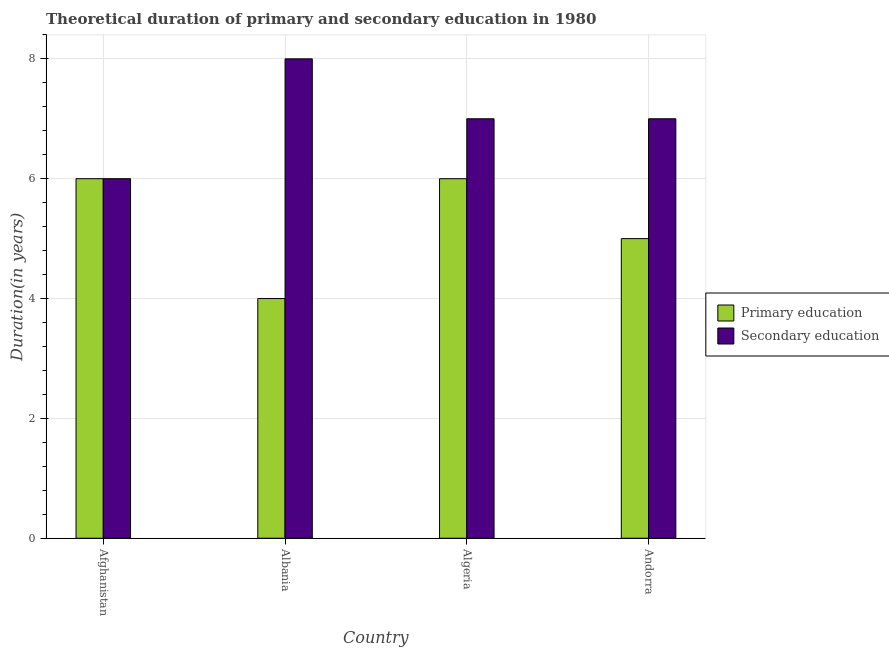How many different coloured bars are there?
Your response must be concise. 2. How many groups of bars are there?
Your answer should be compact. 4. Are the number of bars on each tick of the X-axis equal?
Your answer should be compact. Yes. How many bars are there on the 3rd tick from the left?
Give a very brief answer. 2. What is the label of the 1st group of bars from the left?
Provide a short and direct response. Afghanistan. What is the duration of secondary education in Albania?
Offer a very short reply. 8. Across all countries, what is the maximum duration of secondary education?
Ensure brevity in your answer.  8. In which country was the duration of secondary education maximum?
Provide a short and direct response. Albania. In which country was the duration of primary education minimum?
Make the answer very short. Albania. What is the total duration of primary education in the graph?
Your answer should be compact. 21. What is the difference between the duration of primary education in Albania and that in Andorra?
Your answer should be very brief. -1. What is the difference between the duration of primary education in Algeria and the duration of secondary education in Albania?
Your answer should be very brief. -2. What is the average duration of primary education per country?
Make the answer very short. 5.25. In how many countries, is the duration of secondary education greater than 5.6 years?
Offer a terse response. 4. What is the ratio of the duration of secondary education in Albania to that in Algeria?
Give a very brief answer. 1.14. Is the duration of primary education in Afghanistan less than that in Algeria?
Your answer should be very brief. No. Is the difference between the duration of secondary education in Albania and Algeria greater than the difference between the duration of primary education in Albania and Algeria?
Give a very brief answer. Yes. What is the difference between the highest and the second highest duration of secondary education?
Keep it short and to the point. 1. What is the difference between the highest and the lowest duration of secondary education?
Keep it short and to the point. 2. Is the sum of the duration of secondary education in Afghanistan and Albania greater than the maximum duration of primary education across all countries?
Provide a succinct answer. Yes. How many countries are there in the graph?
Offer a terse response. 4. What is the difference between two consecutive major ticks on the Y-axis?
Offer a terse response. 2. Are the values on the major ticks of Y-axis written in scientific E-notation?
Your answer should be compact. No. Does the graph contain any zero values?
Make the answer very short. No. Where does the legend appear in the graph?
Offer a terse response. Center right. How many legend labels are there?
Your answer should be compact. 2. What is the title of the graph?
Keep it short and to the point. Theoretical duration of primary and secondary education in 1980. What is the label or title of the X-axis?
Keep it short and to the point. Country. What is the label or title of the Y-axis?
Provide a succinct answer. Duration(in years). What is the Duration(in years) in Secondary education in Albania?
Your answer should be compact. 8. What is the Duration(in years) of Primary education in Andorra?
Your answer should be very brief. 5. Across all countries, what is the maximum Duration(in years) of Primary education?
Give a very brief answer. 6. Across all countries, what is the minimum Duration(in years) in Secondary education?
Keep it short and to the point. 6. What is the difference between the Duration(in years) of Primary education in Afghanistan and that in Albania?
Keep it short and to the point. 2. What is the difference between the Duration(in years) of Primary education in Afghanistan and that in Algeria?
Your answer should be compact. 0. What is the difference between the Duration(in years) of Secondary education in Afghanistan and that in Algeria?
Offer a terse response. -1. What is the difference between the Duration(in years) of Secondary education in Afghanistan and that in Andorra?
Provide a short and direct response. -1. What is the difference between the Duration(in years) of Secondary education in Albania and that in Algeria?
Keep it short and to the point. 1. What is the difference between the Duration(in years) of Secondary education in Albania and that in Andorra?
Provide a short and direct response. 1. What is the difference between the Duration(in years) in Primary education in Algeria and that in Andorra?
Offer a terse response. 1. What is the difference between the Duration(in years) of Primary education in Afghanistan and the Duration(in years) of Secondary education in Albania?
Make the answer very short. -2. What is the difference between the Duration(in years) of Primary education in Afghanistan and the Duration(in years) of Secondary education in Algeria?
Your response must be concise. -1. What is the difference between the Duration(in years) in Primary education in Afghanistan and the Duration(in years) in Secondary education in Andorra?
Ensure brevity in your answer.  -1. What is the difference between the Duration(in years) in Primary education in Albania and the Duration(in years) in Secondary education in Andorra?
Your answer should be very brief. -3. What is the average Duration(in years) of Primary education per country?
Give a very brief answer. 5.25. What is the average Duration(in years) in Secondary education per country?
Make the answer very short. 7. What is the difference between the Duration(in years) in Primary education and Duration(in years) in Secondary education in Afghanistan?
Give a very brief answer. 0. What is the difference between the Duration(in years) of Primary education and Duration(in years) of Secondary education in Albania?
Provide a succinct answer. -4. What is the ratio of the Duration(in years) of Secondary education in Afghanistan to that in Algeria?
Make the answer very short. 0.86. What is the ratio of the Duration(in years) of Secondary education in Afghanistan to that in Andorra?
Your answer should be very brief. 0.86. What is the ratio of the Duration(in years) in Secondary education in Albania to that in Algeria?
Offer a very short reply. 1.14. What is the ratio of the Duration(in years) of Primary education in Algeria to that in Andorra?
Offer a terse response. 1.2. What is the ratio of the Duration(in years) in Secondary education in Algeria to that in Andorra?
Give a very brief answer. 1. What is the difference between the highest and the second highest Duration(in years) of Primary education?
Your response must be concise. 0. What is the difference between the highest and the second highest Duration(in years) in Secondary education?
Provide a succinct answer. 1. 